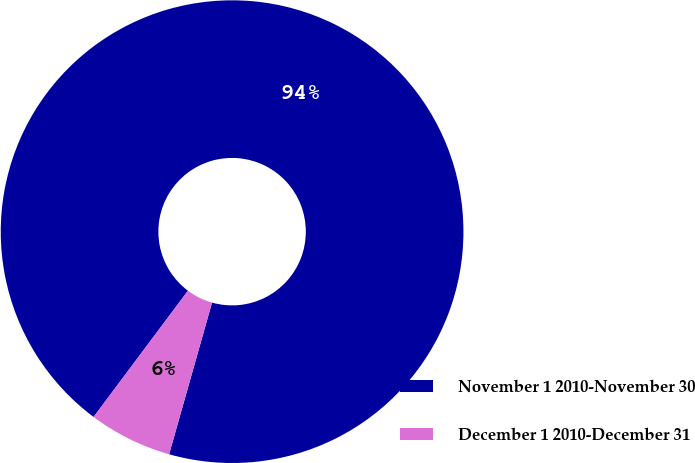Convert chart. <chart><loc_0><loc_0><loc_500><loc_500><pie_chart><fcel>November 1 2010-November 30<fcel>December 1 2010-December 31<nl><fcel>94.17%<fcel>5.83%<nl></chart> 